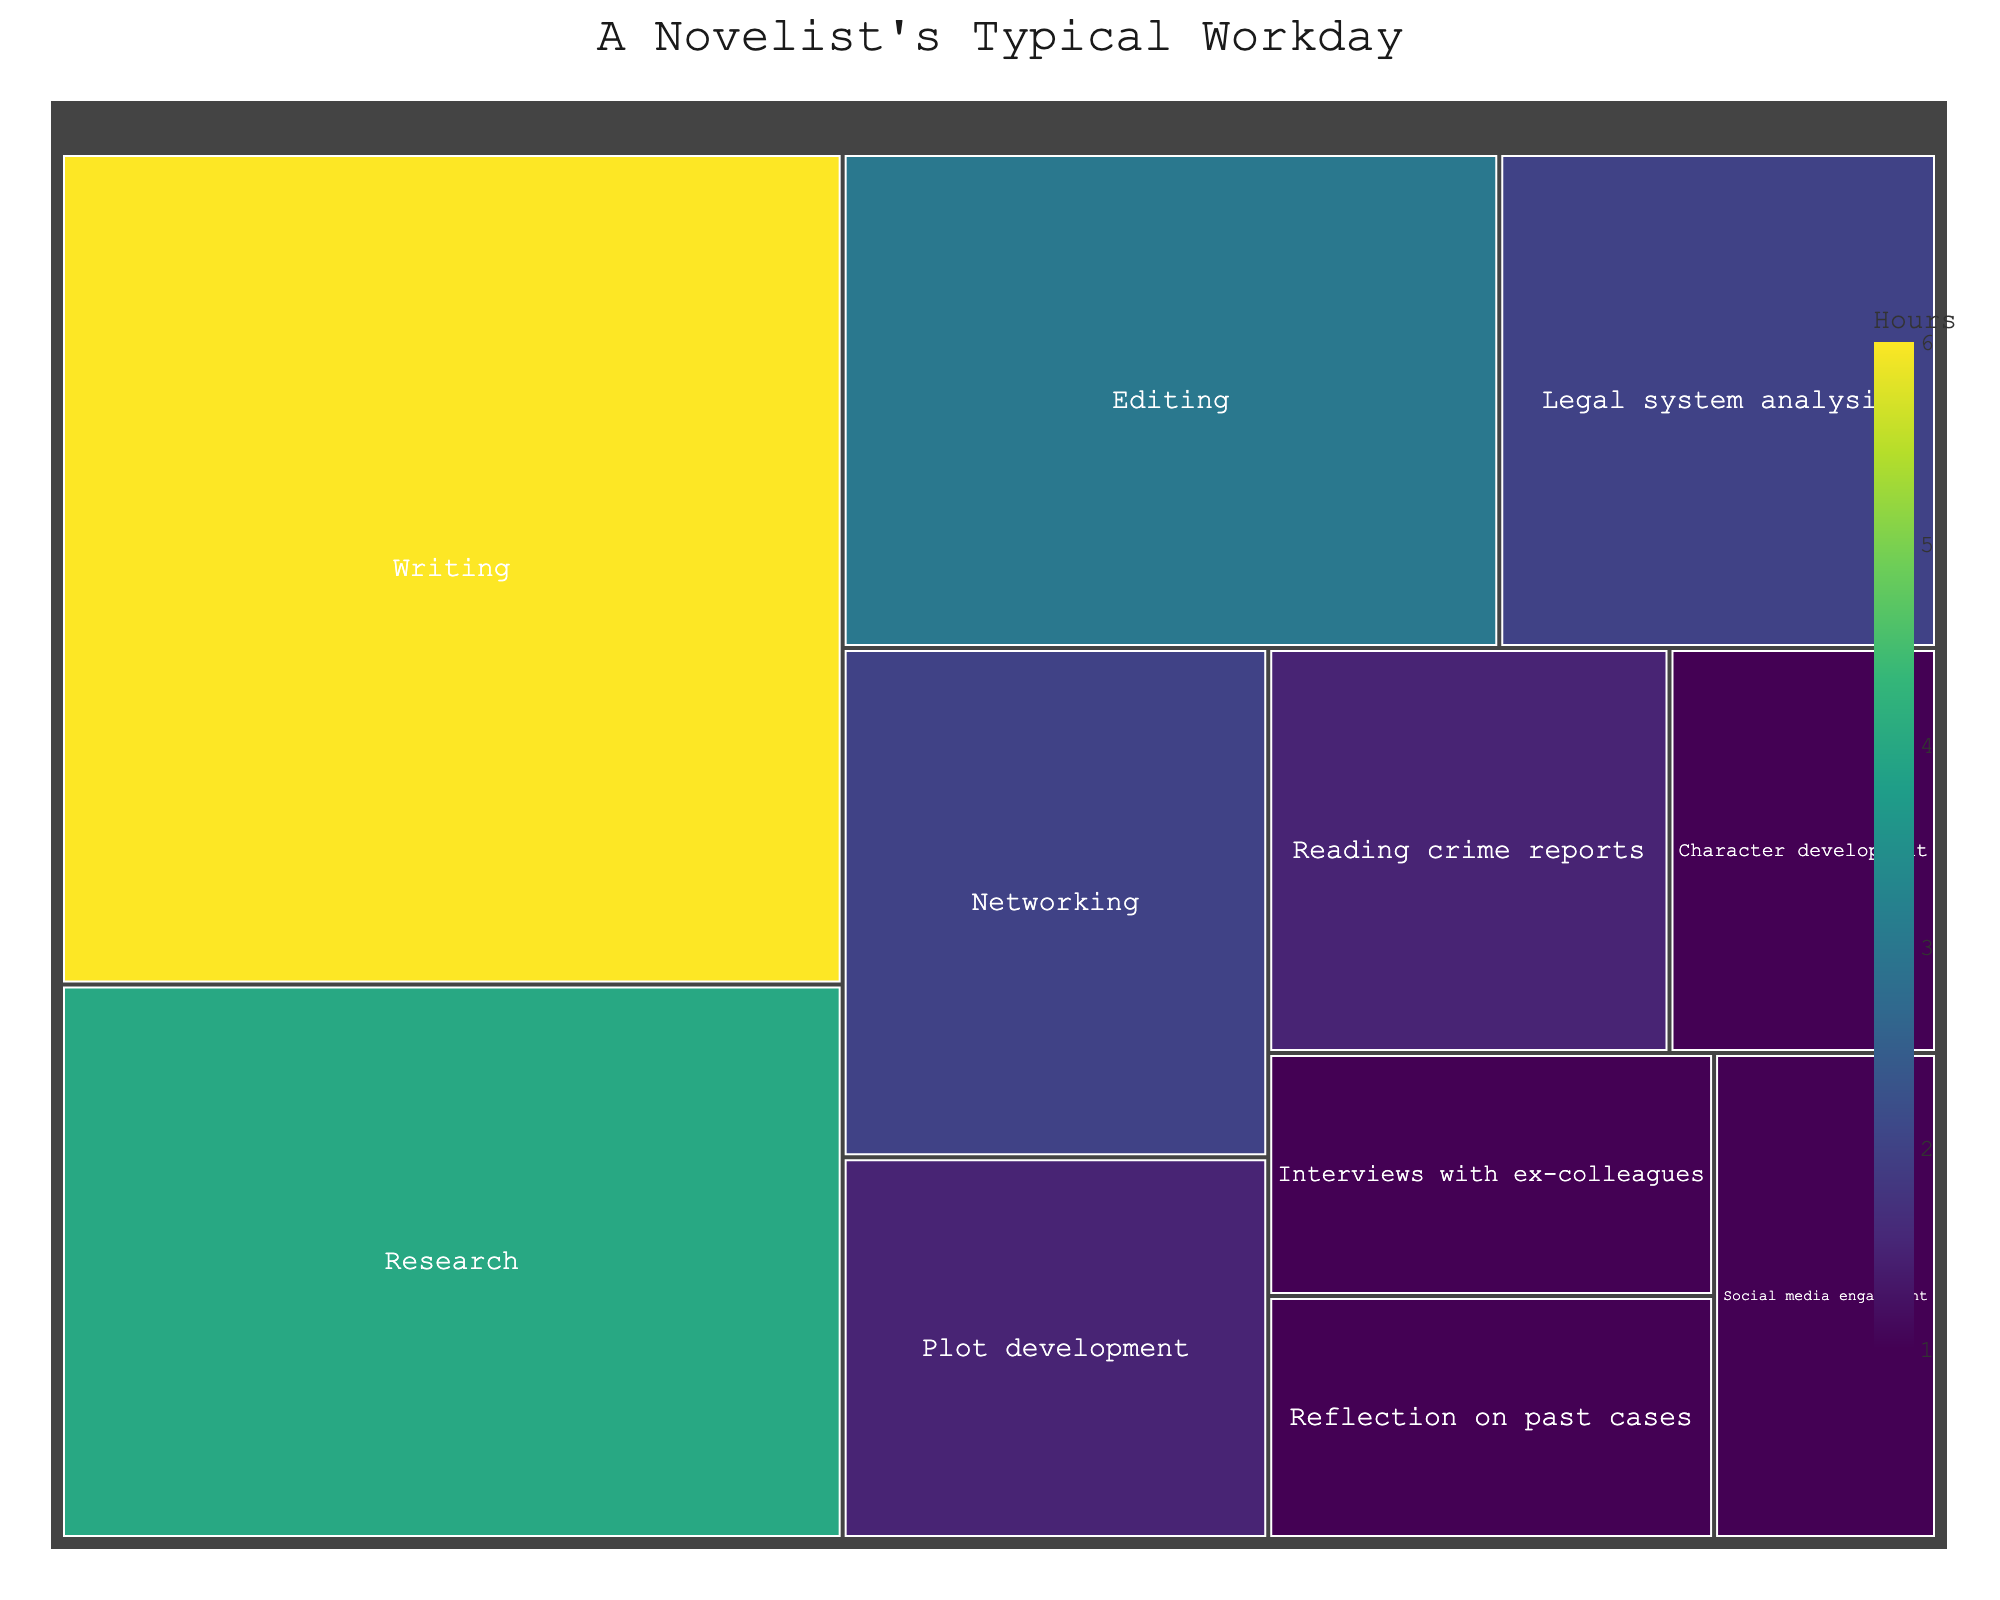What's the title of the plot? The title of the plot is centered at the top and is quite prominent.
Answer: A Novelist's Typical Workday What activity takes the most amount of time? The largest section in a treemap represents the activity that takes the most time. Here, "Writing" occupies the largest area.
Answer: Writing How many hours are spent on "Legal system analysis" and "Reflection on past cases" combined? Find the hours spent on each activity and sum them up. "Legal system analysis" is 2 hours, and "Reflection on past cases" is 1 hour, so the total is 2 + 1.
Answer: 3 hours Which activity is given more time: "Editing" or "Research"? Compare the hours allocated to each activity. "Editing" has 3 hours, whereas "Research" has 4 hours.
Answer: Research What is the total time spent on activities related to "Networking" and "Social media engagement"? Add the hours for "Networking" and "Social media engagement". "Networking" is 2 hours, and "Social media engagement" is 1 hour. So, 2 + 1.
Answer: 3 hours Which activities are allocated exactly 1 hour? Look for activities with 1 hour marked. "Interviews with ex-colleagues," "Character development," and "Reflection on past cases" each have 1 hour.
Answer: Interviews with ex-colleagues, Character development, Reflection on past cases Is more time spent on "Reading crime reports" than on "Plot development"? Compare the sections representing each activity. "Reading crime reports" has 1.5 hours, and "Plot development" also has 1.5 hours.
Answer: No, they are equal What's the combined duration spent on "Reading crime reports," "Interviews with ex-colleagues," and "Networking"? Add the hours for these activities: "Reading crime reports" (1.5), "Interviews with ex-colleagues" (1), and "Networking" (2). So, 1.5 + 1 + 2.
Answer: 4.5 hours Which activities are allotted less than 2 hours? Identify the sections with less than 2 hours. These are "Reading crime reports" (1.5), "Interviews with ex-colleagues" (1), "Social media engagement" (1), "Plot development" (1.5), "Character development" (1), and "Reflection on past cases" (1).
Answer: Reading crime reports, Interviews with ex-colleagues, Social media engagement, Plot development, Character development, Reflection on past cases 